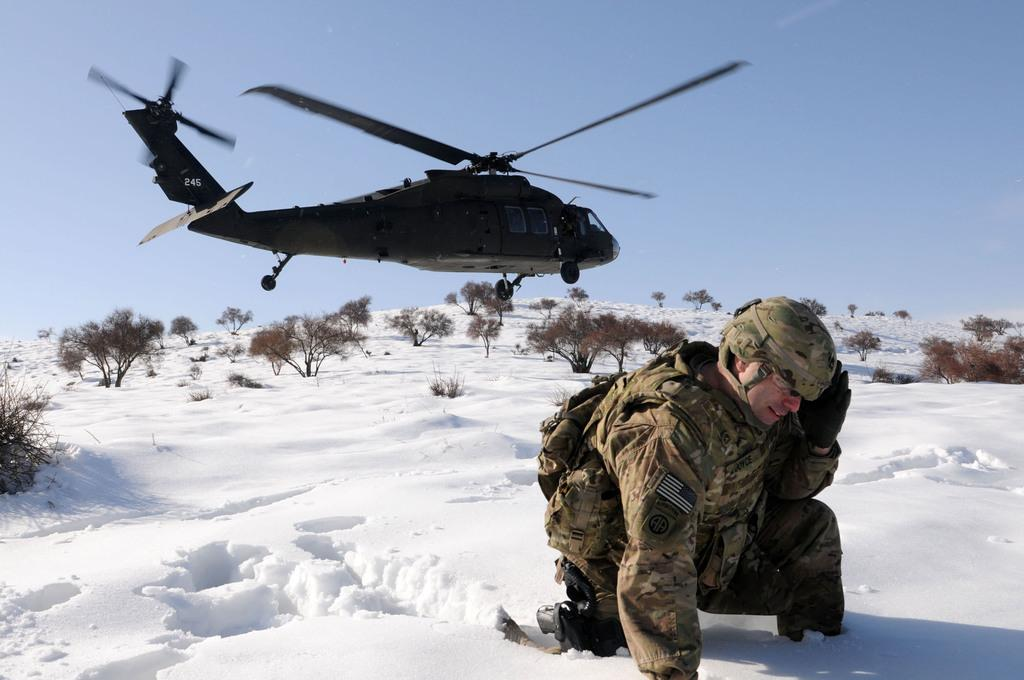Who or what is the main subject in the image? There is a person in the image. What is the person standing on? The person is on snow. What other natural elements can be seen in the image? There are trees in the image. What is flying in the air in the image? There is a helicopter in the air. What can be seen in the background of the image? The sky is visible in the background of the image. What type of brick is the actor holding in the image? There is no actor or brick present in the image. Can you describe the person's reaction to the helicopter in the image? The image does not show the person's reaction to the helicopter; it only shows the person standing on snow with trees in the background. 